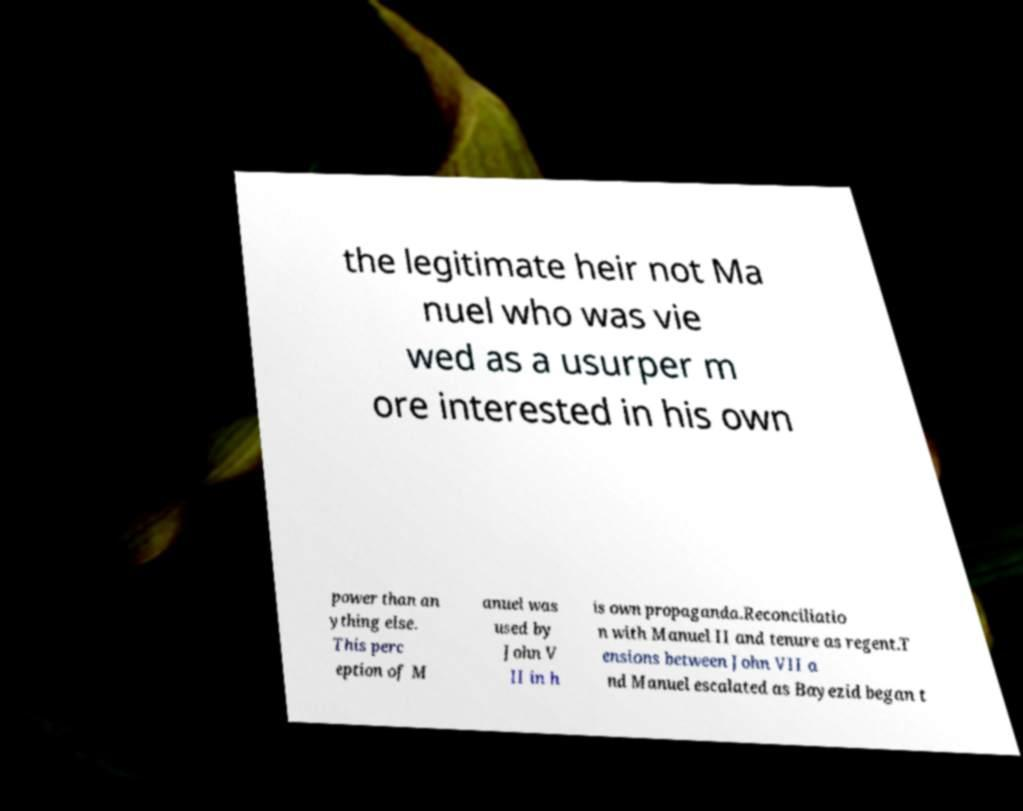Please identify and transcribe the text found in this image. the legitimate heir not Ma nuel who was vie wed as a usurper m ore interested in his own power than an ything else. This perc eption of M anuel was used by John V II in h is own propaganda.Reconciliatio n with Manuel II and tenure as regent.T ensions between John VII a nd Manuel escalated as Bayezid began t 